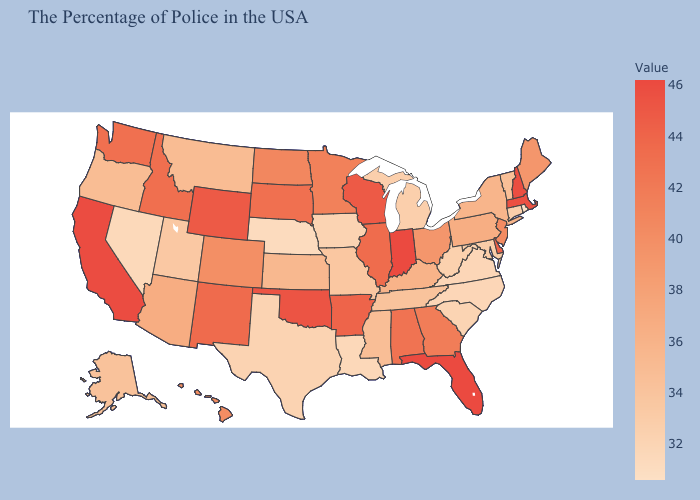Among the states that border Maryland , which have the highest value?
Keep it brief. Delaware. Among the states that border Nebraska , does Wyoming have the highest value?
Short answer required. Yes. Among the states that border Delaware , which have the highest value?
Quick response, please. New Jersey. 